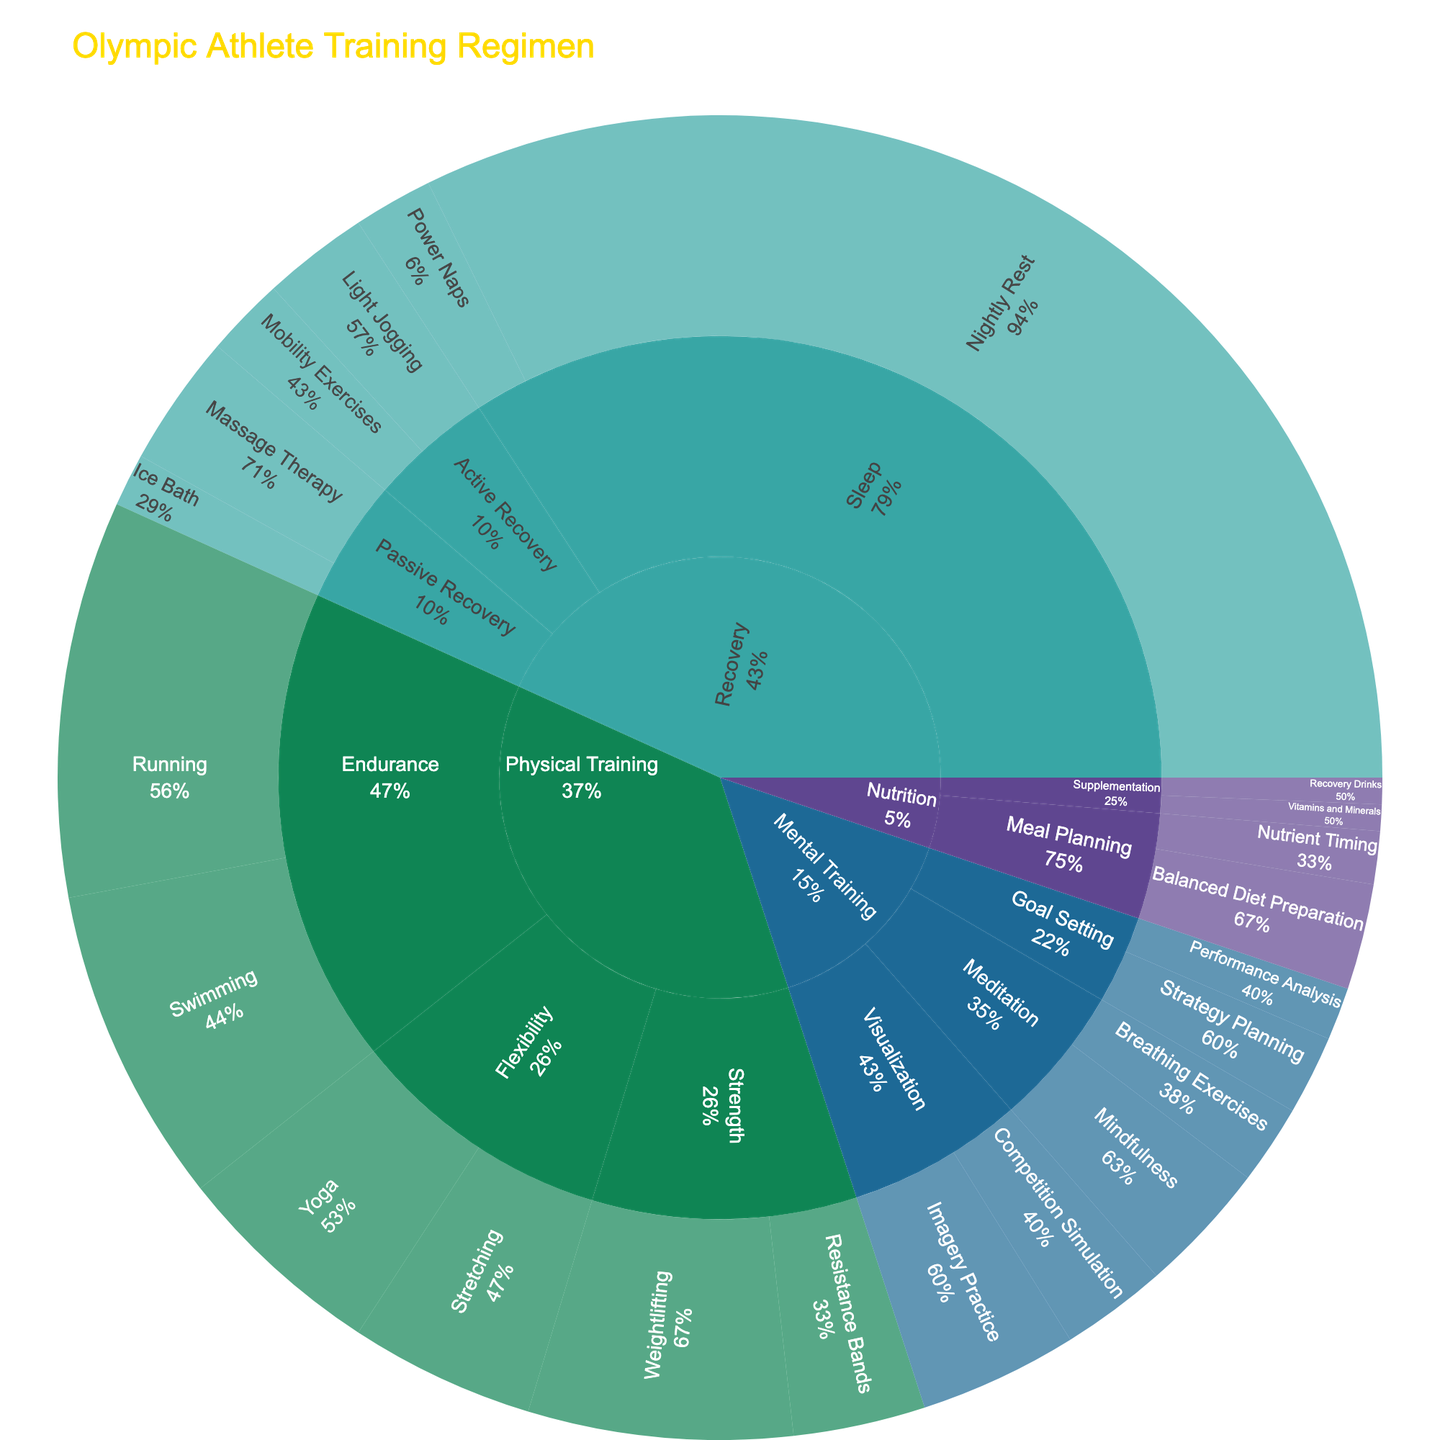What's the total time allocated to Mental Training activities? The sunburst plot divides time allocation into categories including Physical Training, Mental Training, Recovery, and Nutrition. You need to navigate to the Mental Training category and sum all activities' times: 6 (Imagery Practice) + 4 (Competition Simulation) + 5 (Mindfulness) + 3 (Breathing Exercises) + 2 (Performance Analysis) + 3 (Strategy Planning) = 23 hours
Answer: 23 hours Which category has the single largest allocation of time? From the sunburst plot, you identify the largest section which corresponds to high values or a big visual area. The Sleep subcategory under Recovery has the largest allocation with Nightly Rest being 50 hours
Answer: Recovery How does the time spent on Strength training compare to Flexibility training? Navigate to Physical Training and look at subsets for Strength (Weightlifting + Resistance Bands) and Flexibility (Yoga + Stretching). Sum them up as follows: Strength: 10 (Weightlifting) + 5 (Resistance Bands) = 15 hours. Flexibility: 8 (Yoga) + 7 (Stretching) = 15 hours. Comparison: Strength and Flexibility both have equal time allocation of 15 hours each.
Answer: They are equal Within Recovery, which activity takes up more time: Passive Recovery or Sleep? Go to the Recovery category and check the subcategories: Passive Recovery (Massage Therapy + Ice Bath) and Sleep (Nightly Rest + Power Naps). Sum them up: Passive Recovery: 5 (Massage Therapy) + 2 (Ice Bath) = 7 hours. Sleep: 50 (Nightly Rest) + 3 (Power Naps) = 53 hours. Comparison clearly shows Sleep has more time allocated
Answer: Sleep What's the percentage of time allocated to Visualization activities within Mental Training? Focus on the Visualization subcategory under Mental Training, which includes Imagery Practice and Competition Simulation. Calculate their combined time first: 6 + 4 = 10 hours. Then, Mental Training total is 23 hours. Percentage = (10 / 23) * 100 = 43.5%
Answer: 43.5% Which has more time allocation, Supplements within Nutrition or Active Recovery? Calculate for both Supplements under Nutrition and Active Recovery under Recovery. Supplements: 1 (Vitamins and Minerals) + 1 (Recovery Drinks) = 2 hours. Active Recovery: 4 (Light Jogging) + 3 (Mobility Exercises) = 7 hours. Active Recovery has more time
Answer: Active Recovery Compare the total time for Physical Training activities to the combined total of Nutrition and Recovery activities. First, calculate for Physical Training: Strength (15 hours) + Endurance (27 hours) + Flexibility (15 hours) = 57 hours. 
Nutrition: Meal Planning (6 hours) + Supplementation (2 hours) = 8 hours.
Recovery: Active Recovery (7 hours) + Passive Recovery (7 hours) + Sleep (53 hours) = 67 hours.
Sum of Nutrition and Recovery: 8 (Nutrition) + 67 (Recovery) = 75 hours. Thus, Nutrition and Recovery combined have more time compared to Physical Training
Answer: Nutrition and Recovery combined What fraction of total training regimen time is spent on Nutrition activities? Calculate total time: Sum all times (Physical + Mental + Recovery + Nutrition): 57 (Physical) + 23 (Mental) + 67 (Recovery) + 8 (Nutrition) = 155 hours. Fraction of Nutrition: 8/155
Answer: 8/155 